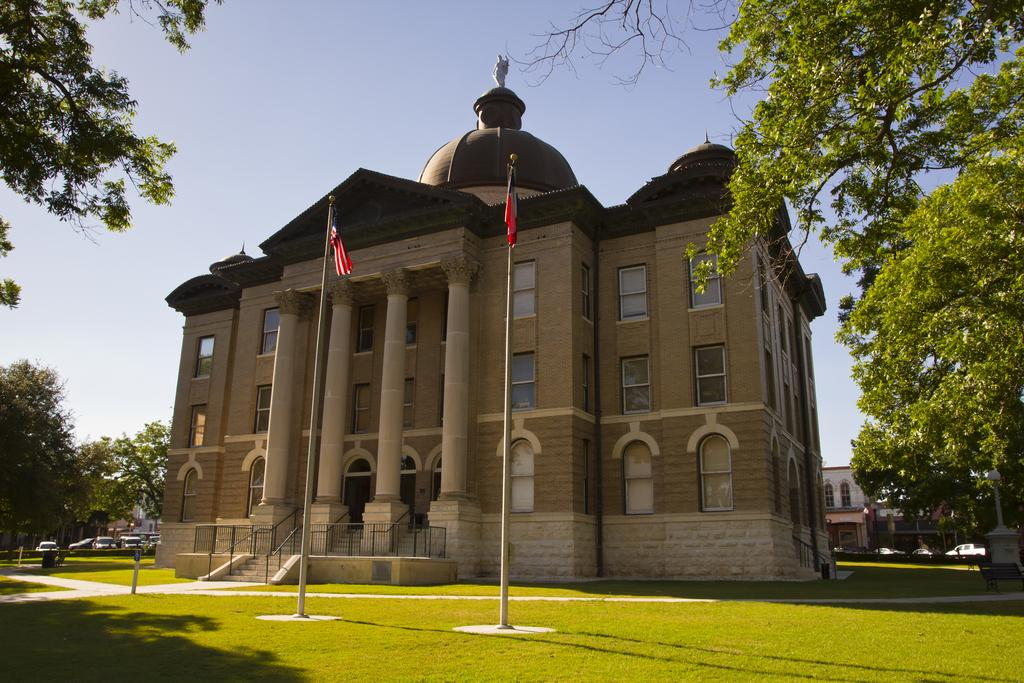What type of vegetation can be seen in the image? There are trees in the image. What type of man-made structures are visible in the image? There is a building in the middle of the image. What are the flagpoles used for in the image? The flagpoles are in front of the building. What is visible at the top of the image? The sky is visible at the top of the image. Can you hear the horn of the car in the image? There is no sound present in the image, so it is not possible to hear a horn. What type of fork is being used by the trees in the image? There are no forks present in the image, and trees do not use forks. 